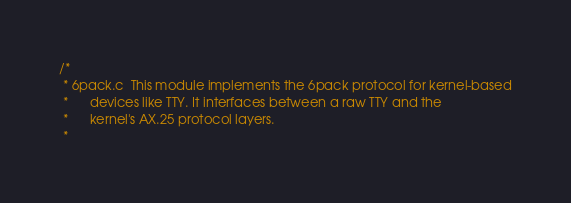<code> <loc_0><loc_0><loc_500><loc_500><_C_>/*
 * 6pack.c	This module implements the 6pack protocol for kernel-based
 *		devices like TTY. It interfaces between a raw TTY and the
 *		kernel's AX.25 protocol layers.
 *</code> 